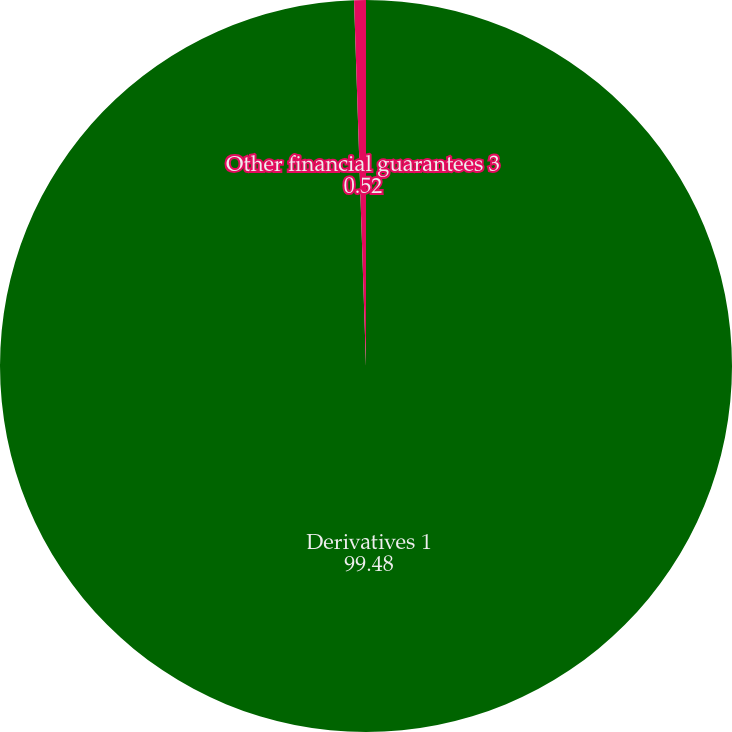Convert chart. <chart><loc_0><loc_0><loc_500><loc_500><pie_chart><fcel>Derivatives 1<fcel>Other financial guarantees 3<nl><fcel>99.48%<fcel>0.52%<nl></chart> 